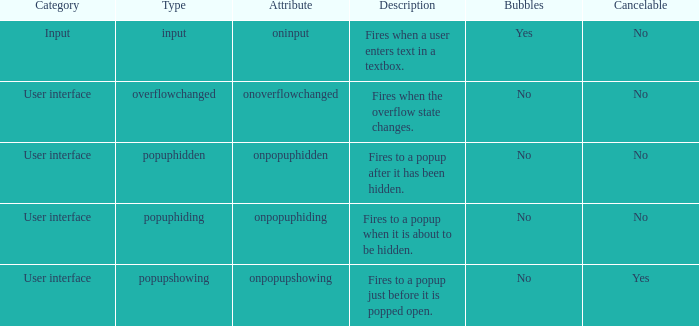What's the type with description being fires when the overflow state changes. Overflowchanged. 